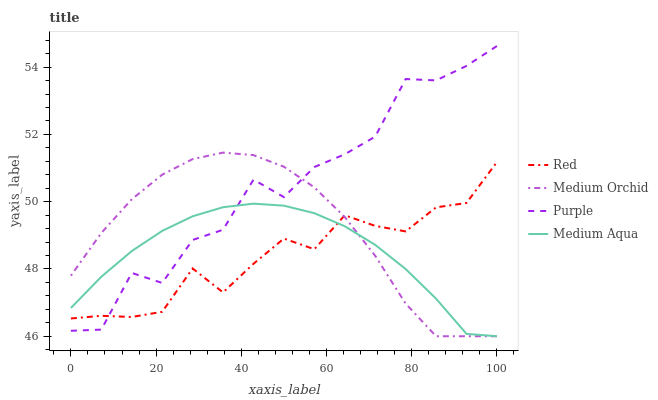Does Medium Orchid have the minimum area under the curve?
Answer yes or no. No. Does Medium Orchid have the maximum area under the curve?
Answer yes or no. No. Is Medium Orchid the smoothest?
Answer yes or no. No. Is Medium Orchid the roughest?
Answer yes or no. No. Does Red have the lowest value?
Answer yes or no. No. Does Medium Orchid have the highest value?
Answer yes or no. No. 